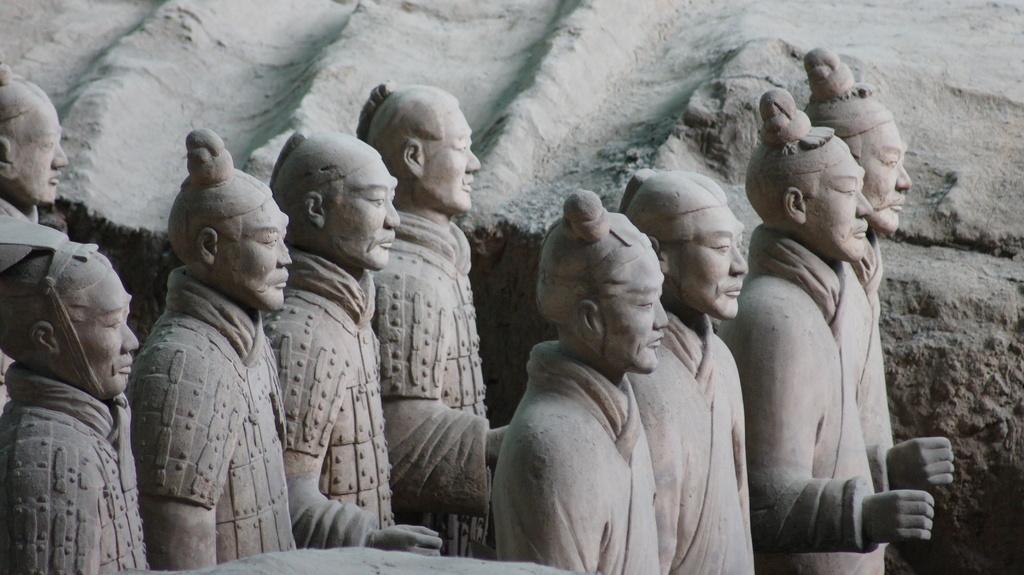Please provide a concise description of this image. In this image I can see sculptures of few people. 